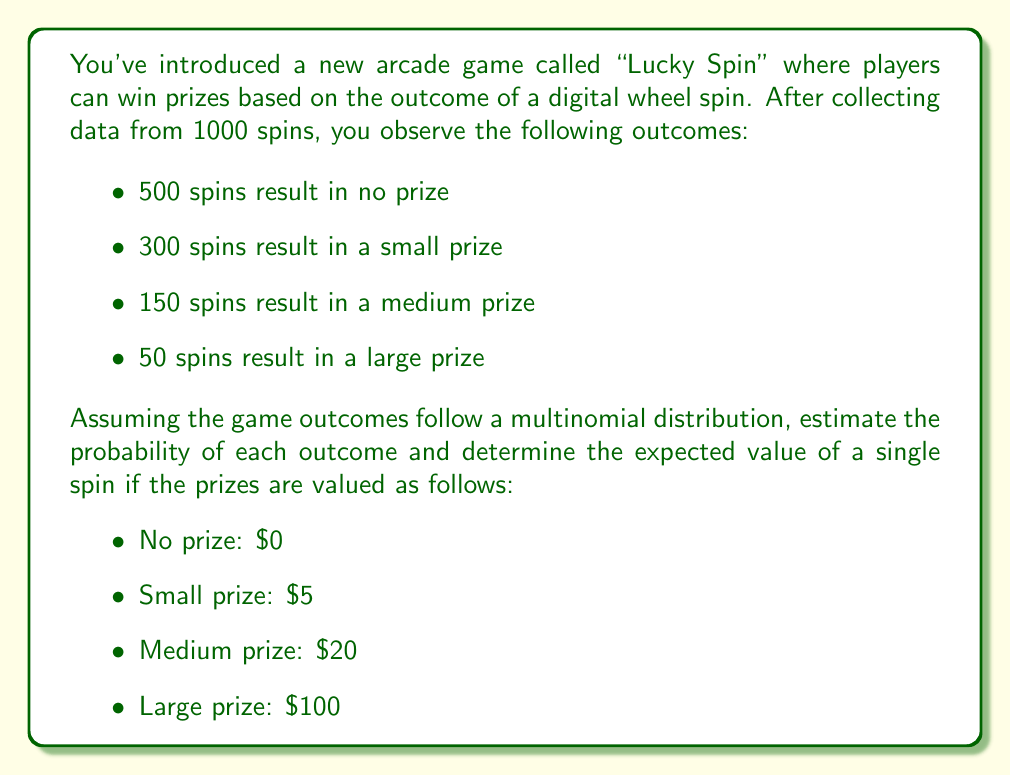Show me your answer to this math problem. To solve this problem, we'll follow these steps:

1. Estimate the probabilities of each outcome:
   The probability of each outcome can be estimated by dividing the number of occurrences by the total number of spins.

   $p(\text{no prize}) = \frac{500}{1000} = 0.5$
   $p(\text{small prize}) = \frac{300}{1000} = 0.3$
   $p(\text{medium prize}) = \frac{150}{1000} = 0.15$
   $p(\text{large prize}) = \frac{50}{1000} = 0.05$

2. Calculate the expected value:
   The expected value is the sum of each outcome's probability multiplied by its corresponding value.

   $$E = \sum_{i=1}^{n} p_i \cdot v_i$$

   Where $p_i$ is the probability of outcome $i$, and $v_i$ is the value of outcome $i$.

   $$E = (0.5 \cdot \$0) + (0.3 \cdot \$5) + (0.15 \cdot \$20) + (0.05 \cdot \$100)$$
   $$E = \$0 + \$1.50 + \$3.00 + \$5.00$$
   $$E = \$9.50$$

Therefore, the expected value of a single spin is $9.50.
Answer: $9.50 